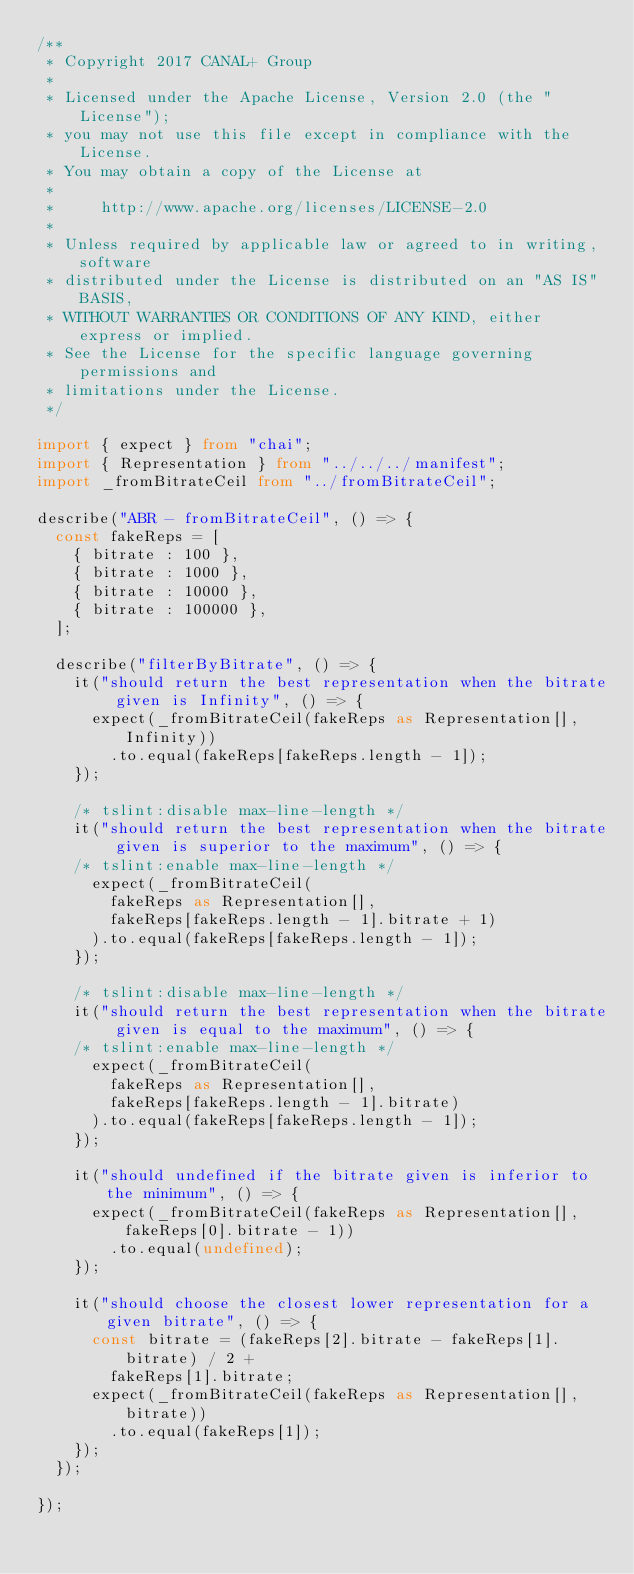Convert code to text. <code><loc_0><loc_0><loc_500><loc_500><_TypeScript_>/**
 * Copyright 2017 CANAL+ Group
 *
 * Licensed under the Apache License, Version 2.0 (the "License");
 * you may not use this file except in compliance with the License.
 * You may obtain a copy of the License at
 *
 *     http://www.apache.org/licenses/LICENSE-2.0
 *
 * Unless required by applicable law or agreed to in writing, software
 * distributed under the License is distributed on an "AS IS" BASIS,
 * WITHOUT WARRANTIES OR CONDITIONS OF ANY KIND, either express or implied.
 * See the License for the specific language governing permissions and
 * limitations under the License.
 */

import { expect } from "chai";
import { Representation } from "../../../manifest";
import _fromBitrateCeil from "../fromBitrateCeil";

describe("ABR - fromBitrateCeil", () => {
  const fakeReps = [
    { bitrate : 100 },
    { bitrate : 1000 },
    { bitrate : 10000 },
    { bitrate : 100000 },
  ];

  describe("filterByBitrate", () => {
    it("should return the best representation when the bitrate given is Infinity", () => {
      expect(_fromBitrateCeil(fakeReps as Representation[], Infinity))
        .to.equal(fakeReps[fakeReps.length - 1]);
    });

    /* tslint:disable max-line-length */
    it("should return the best representation when the bitrate given is superior to the maximum", () => {
    /* tslint:enable max-line-length */
      expect(_fromBitrateCeil(
        fakeReps as Representation[],
        fakeReps[fakeReps.length - 1].bitrate + 1)
      ).to.equal(fakeReps[fakeReps.length - 1]);
    });

    /* tslint:disable max-line-length */
    it("should return the best representation when the bitrate given is equal to the maximum", () => {
    /* tslint:enable max-line-length */
      expect(_fromBitrateCeil(
        fakeReps as Representation[],
        fakeReps[fakeReps.length - 1].bitrate)
      ).to.equal(fakeReps[fakeReps.length - 1]);
    });

    it("should undefined if the bitrate given is inferior to the minimum", () => {
      expect(_fromBitrateCeil(fakeReps as Representation[], fakeReps[0].bitrate - 1))
        .to.equal(undefined);
    });

    it("should choose the closest lower representation for a given bitrate", () => {
      const bitrate = (fakeReps[2].bitrate - fakeReps[1].bitrate) / 2 +
        fakeReps[1].bitrate;
      expect(_fromBitrateCeil(fakeReps as Representation[], bitrate))
        .to.equal(fakeReps[1]);
    });
  });

});
</code> 